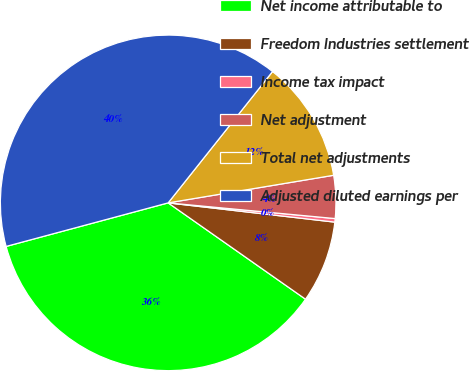Convert chart. <chart><loc_0><loc_0><loc_500><loc_500><pie_chart><fcel>Net income attributable to<fcel>Freedom Industries settlement<fcel>Income tax impact<fcel>Net adjustment<fcel>Total net adjustments<fcel>Adjusted diluted earnings per<nl><fcel>36.08%<fcel>7.9%<fcel>0.34%<fcel>4.12%<fcel>11.68%<fcel>39.86%<nl></chart> 